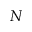Convert formula to latex. <formula><loc_0><loc_0><loc_500><loc_500>N</formula> 